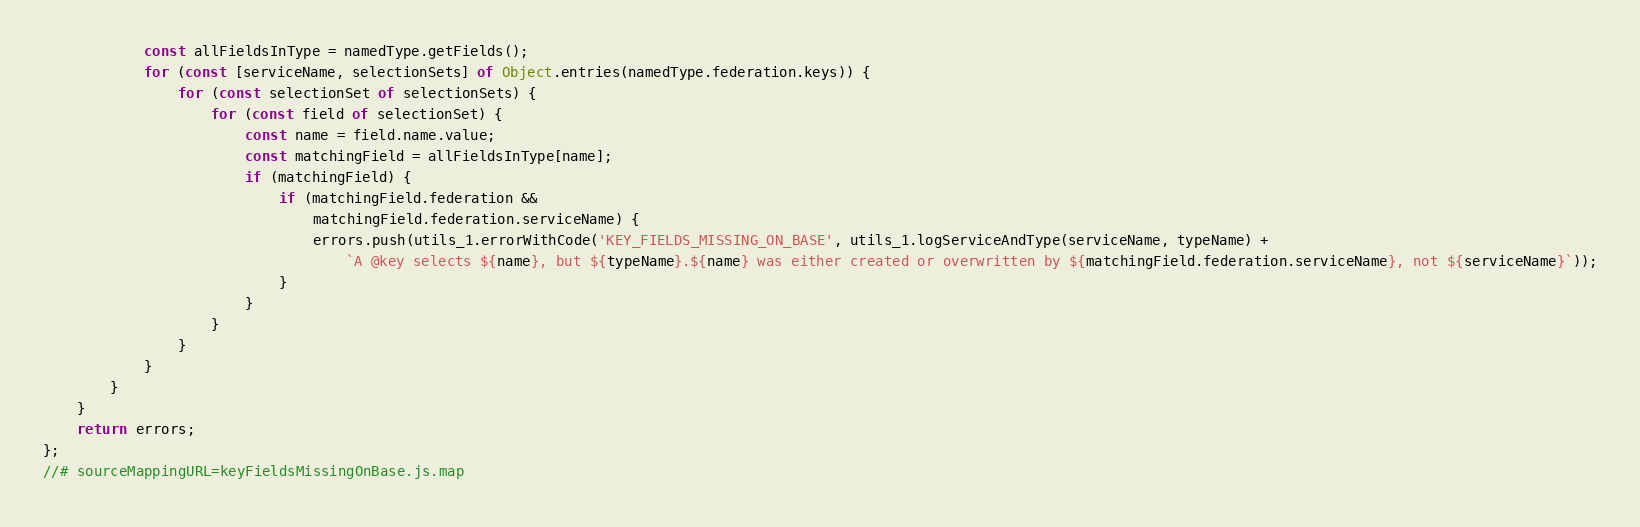Convert code to text. <code><loc_0><loc_0><loc_500><loc_500><_JavaScript_>            const allFieldsInType = namedType.getFields();
            for (const [serviceName, selectionSets] of Object.entries(namedType.federation.keys)) {
                for (const selectionSet of selectionSets) {
                    for (const field of selectionSet) {
                        const name = field.name.value;
                        const matchingField = allFieldsInType[name];
                        if (matchingField) {
                            if (matchingField.federation &&
                                matchingField.federation.serviceName) {
                                errors.push(utils_1.errorWithCode('KEY_FIELDS_MISSING_ON_BASE', utils_1.logServiceAndType(serviceName, typeName) +
                                    `A @key selects ${name}, but ${typeName}.${name} was either created or overwritten by ${matchingField.federation.serviceName}, not ${serviceName}`));
                            }
                        }
                    }
                }
            }
        }
    }
    return errors;
};
//# sourceMappingURL=keyFieldsMissingOnBase.js.map</code> 